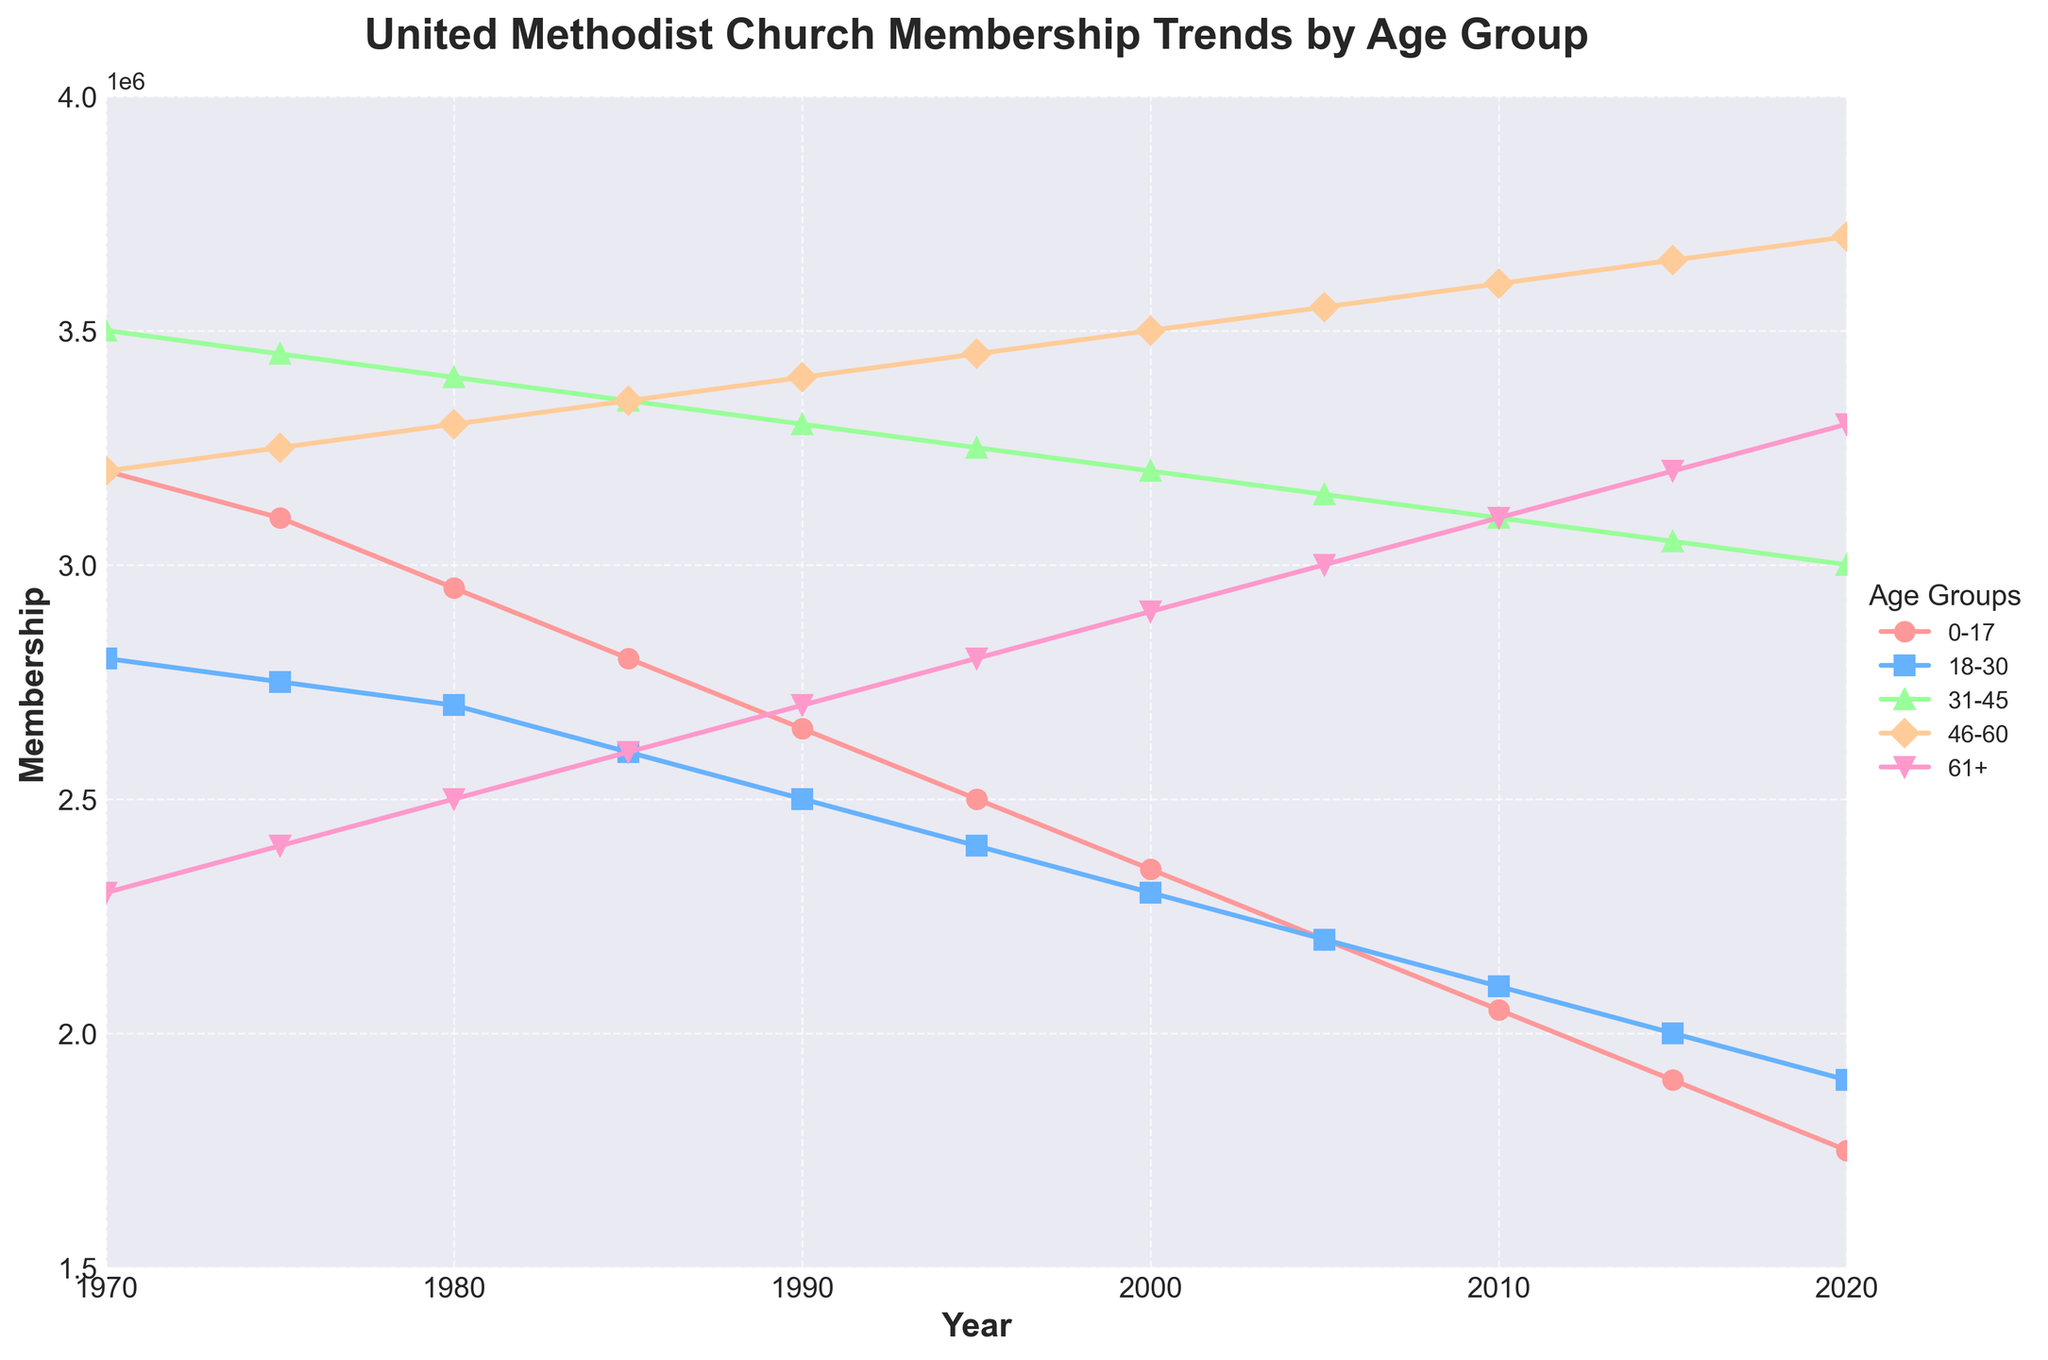Which age group had the highest membership in 2020? In the plot, the line representing the age group 46-60 is at the highest point at the end of the timeline in 2020, indicating that this age group had the highest membership that year.
Answer: 46-60 What is the difference in membership between the 0-17 age group and the 61+ age group in 1970? According to the plot, the membership for the 0-17 age group in 1970 was 3,200,000, and for the 61+ age group, it was 2,300,000. The difference is 3,200,000 - 2,300,000 = 900,000.
Answer: 900,000 Which age group showed the most consistent decline in membership over the 50 years? The line representing the 0-17 age group shows a gradual and consistent downward trend from 1970 to 2020.
Answer: 0-17 In what year did the 46-60 age group surpass the 31-45 age group in membership? By examining the intersection of the lines, it can be seen that the 46-60 age group surpassed the 31-45 age group in membership around the year 2005.
Answer: 2005 What is the total membership in 1990 combining the 0-17 and 61+ age groups? From the plot, the membership in 1990 for the 0-17 age group is 2,650,000, and for the 61+ age group, it is 2,700,000. Adding them together yields 2,650,000 + 2,700,000 = 5,350,000.
Answer: 5,350,000 Which age group had the smallest change in membership between 1970 and 2020? By looking at the changes in the lines, the age group 61+ shows a gradual increase, with a final difference of only 1,000,000 (from 2,300,000 in 1970 to 3,300,000 in 2020), which is the smallest change compared to the others.
Answer: 61+ During what period did the 18-30 age group have the steepest decline in membership? The visually steepest decline in the line for the 18-30 age group is noticeable between 1970 and 1980.
Answer: 1970-1980 Which age group's membership remained relatively stable between 2000 and 2020? Observing the lines, the age group 31-45 shows a relatively stable membership between 2000 and 2020, with only slight fluctuations.
Answer: 31-45 What was the average membership of the 46-60 age group over the entire period? To find the average membership, sum the memberships from each decade for the 46-60 group: 3,200,000 + 3,250,000 + 3,300,000 + 3,350,000 + 3,400,000 + 3,450,000 + 3,500,000 + 3,550,000 + 3,600,000 + 3,650,000 + 3,700,000 = 36,000,000. Divide by 11 (years): 36,000,000 / 11 ≈ 3,272,727.
Answer: ≈ 3,272,727 